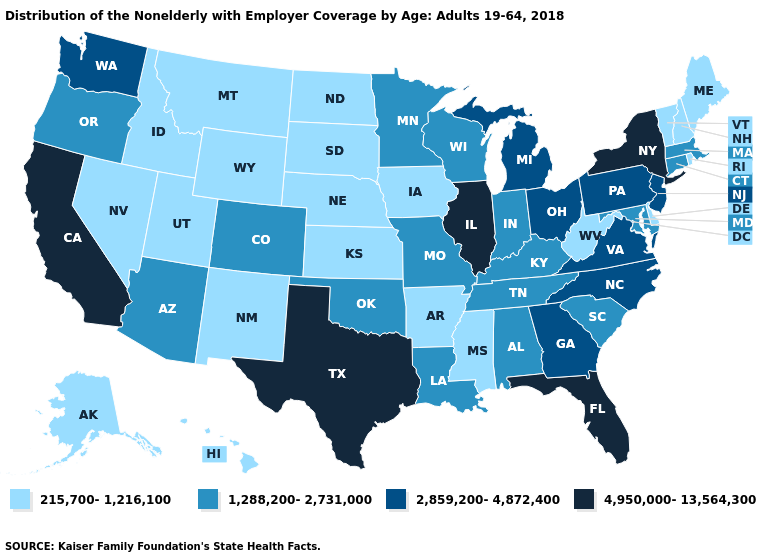Does the first symbol in the legend represent the smallest category?
Give a very brief answer. Yes. What is the value of New Hampshire?
Write a very short answer. 215,700-1,216,100. Among the states that border Massachusetts , does New York have the lowest value?
Write a very short answer. No. Name the states that have a value in the range 1,288,200-2,731,000?
Write a very short answer. Alabama, Arizona, Colorado, Connecticut, Indiana, Kentucky, Louisiana, Maryland, Massachusetts, Minnesota, Missouri, Oklahoma, Oregon, South Carolina, Tennessee, Wisconsin. Name the states that have a value in the range 4,950,000-13,564,300?
Concise answer only. California, Florida, Illinois, New York, Texas. What is the highest value in the Northeast ?
Short answer required. 4,950,000-13,564,300. What is the value of Alabama?
Write a very short answer. 1,288,200-2,731,000. What is the value of Vermont?
Answer briefly. 215,700-1,216,100. What is the value of North Carolina?
Write a very short answer. 2,859,200-4,872,400. What is the value of Vermont?
Concise answer only. 215,700-1,216,100. What is the value of New York?
Quick response, please. 4,950,000-13,564,300. Does Iowa have the highest value in the MidWest?
Write a very short answer. No. Does Alaska have the same value as Texas?
Answer briefly. No. What is the value of Washington?
Short answer required. 2,859,200-4,872,400. Among the states that border Arkansas , which have the lowest value?
Answer briefly. Mississippi. 